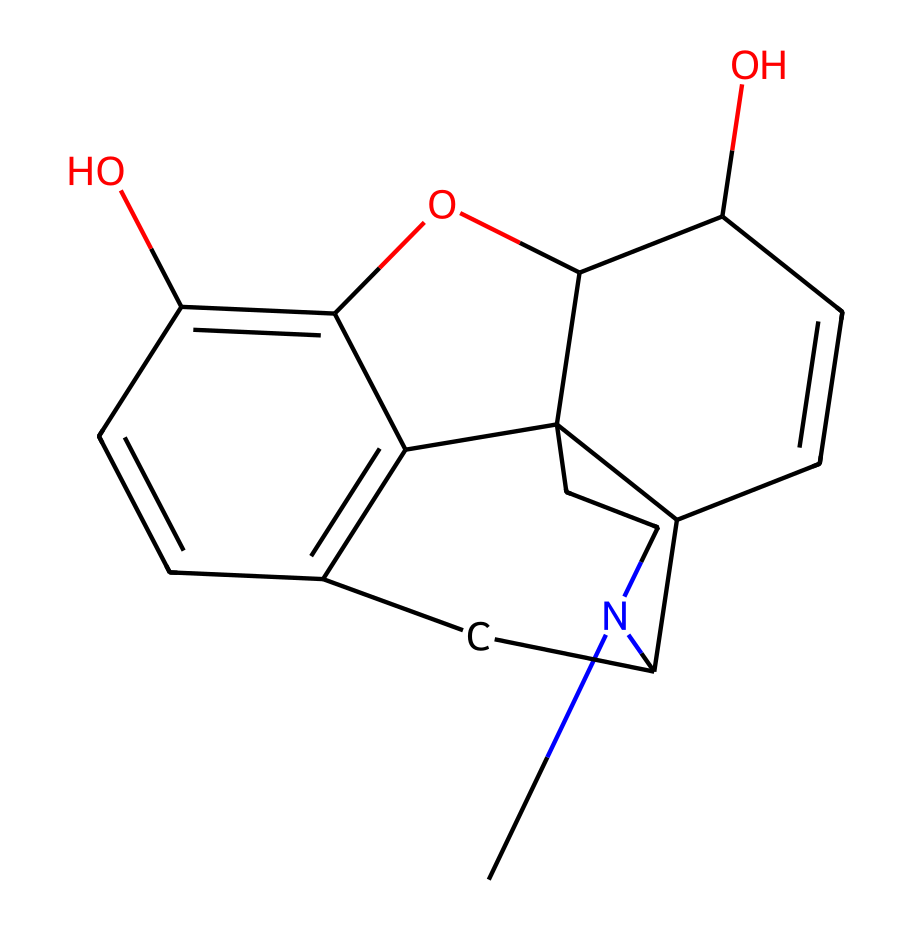What is the molecular formula of morphine? To deduce the molecular formula, count the number of each type of atom present in the structure. The SMILES representation reveals 17 carbon atoms, 19 hydrogen atoms, 3 oxygen atoms, and 1 nitrogen atom. Therefore, the molecular formula is C17H19N3O3.
Answer: C17H19N3O3 How many rings are present in the structure of morphine? Analyzing the SMILES, we notice that the notation indicates cyclic structures (denoted by 'N1', 'C2', and 'C3'). Counting these indicates that morphine contains 5 ring structures in total.
Answer: 5 Which functional group is primarily responsible for morphine's analgesic properties? Observing the structure, the hydroxyl (-OH) groups are key contributors to its pharmacological activity as they interact with receptors. The presence of these hydroxyl groups enables pain relief.
Answer: hydroxyl groups How many oxygen atoms are in the structure of morphine? Looking at the SMILES representation, we identify all the oxygen atoms, and there are exactly 3 oxygen atoms present in the chemical structure.
Answer: 3 What type of chemical compound is morphine classified as? Understanding the presence of nitrogen in the structure and analyzing its properties leads us to the classification of morphine as an alkaloid, which is a nitrogen-containing compound derived from plant sources.
Answer: alkaloid Are there any chiral centers in morphine? By scrutinizing the structure for stereocenters, we find that morphine has multiple chiral centers (as evidenced by the carbon atoms attached to different substituents), certifying its chirality that influences its biological activity.
Answer: yes 